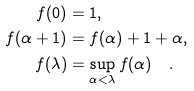<formula> <loc_0><loc_0><loc_500><loc_500>f ( 0 ) & = 1 , \\ f ( \alpha + 1 ) & = f ( \alpha ) + 1 + \alpha , \\ f ( \lambda ) & = \sup _ { \alpha < \lambda } f ( \alpha ) \quad .</formula> 